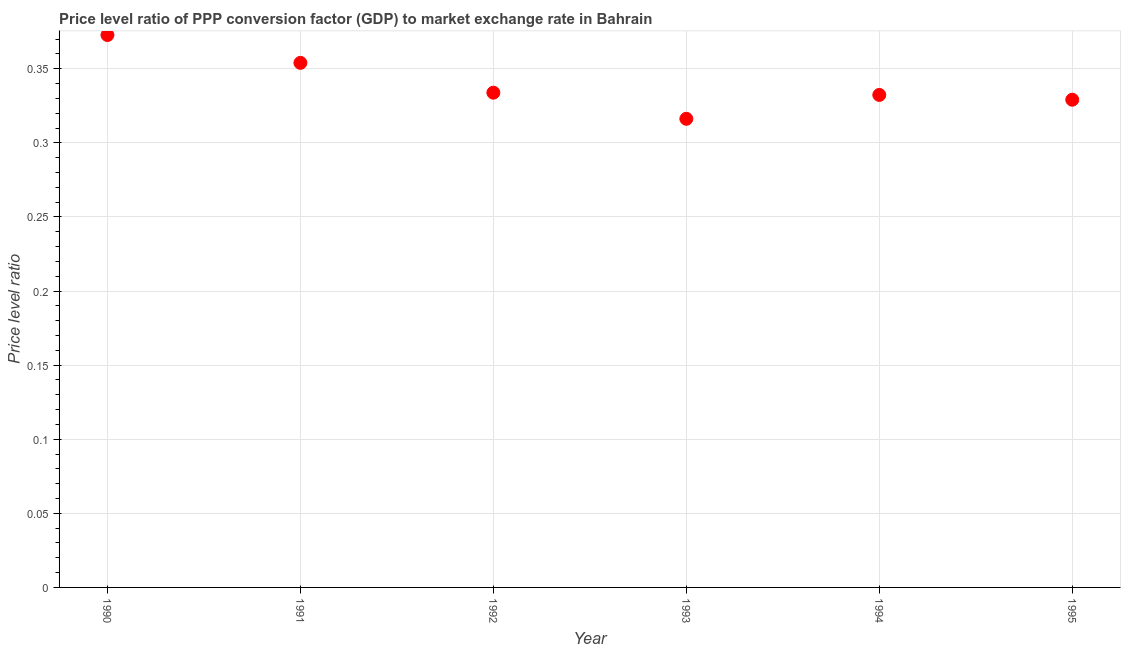What is the price level ratio in 1994?
Give a very brief answer. 0.33. Across all years, what is the maximum price level ratio?
Give a very brief answer. 0.37. Across all years, what is the minimum price level ratio?
Your answer should be very brief. 0.32. In which year was the price level ratio maximum?
Provide a short and direct response. 1990. In which year was the price level ratio minimum?
Provide a succinct answer. 1993. What is the sum of the price level ratio?
Your answer should be compact. 2.04. What is the difference between the price level ratio in 1990 and 1993?
Provide a succinct answer. 0.06. What is the average price level ratio per year?
Provide a short and direct response. 0.34. What is the median price level ratio?
Provide a short and direct response. 0.33. Do a majority of the years between 1993 and 1990 (inclusive) have price level ratio greater than 0.29 ?
Your answer should be compact. Yes. What is the ratio of the price level ratio in 1990 to that in 1992?
Give a very brief answer. 1.12. Is the difference between the price level ratio in 1991 and 1994 greater than the difference between any two years?
Ensure brevity in your answer.  No. What is the difference between the highest and the second highest price level ratio?
Your answer should be compact. 0.02. What is the difference between the highest and the lowest price level ratio?
Provide a short and direct response. 0.06. Does the graph contain any zero values?
Your response must be concise. No. What is the title of the graph?
Make the answer very short. Price level ratio of PPP conversion factor (GDP) to market exchange rate in Bahrain. What is the label or title of the Y-axis?
Offer a terse response. Price level ratio. What is the Price level ratio in 1990?
Your answer should be very brief. 0.37. What is the Price level ratio in 1991?
Provide a succinct answer. 0.35. What is the Price level ratio in 1992?
Offer a terse response. 0.33. What is the Price level ratio in 1993?
Ensure brevity in your answer.  0.32. What is the Price level ratio in 1994?
Your answer should be very brief. 0.33. What is the Price level ratio in 1995?
Give a very brief answer. 0.33. What is the difference between the Price level ratio in 1990 and 1991?
Your response must be concise. 0.02. What is the difference between the Price level ratio in 1990 and 1992?
Offer a very short reply. 0.04. What is the difference between the Price level ratio in 1990 and 1993?
Your answer should be compact. 0.06. What is the difference between the Price level ratio in 1990 and 1994?
Keep it short and to the point. 0.04. What is the difference between the Price level ratio in 1990 and 1995?
Your answer should be very brief. 0.04. What is the difference between the Price level ratio in 1991 and 1992?
Keep it short and to the point. 0.02. What is the difference between the Price level ratio in 1991 and 1993?
Keep it short and to the point. 0.04. What is the difference between the Price level ratio in 1991 and 1994?
Your answer should be very brief. 0.02. What is the difference between the Price level ratio in 1991 and 1995?
Offer a very short reply. 0.02. What is the difference between the Price level ratio in 1992 and 1993?
Provide a succinct answer. 0.02. What is the difference between the Price level ratio in 1992 and 1994?
Offer a very short reply. 0. What is the difference between the Price level ratio in 1992 and 1995?
Ensure brevity in your answer.  0. What is the difference between the Price level ratio in 1993 and 1994?
Ensure brevity in your answer.  -0.02. What is the difference between the Price level ratio in 1993 and 1995?
Your answer should be compact. -0.01. What is the difference between the Price level ratio in 1994 and 1995?
Provide a short and direct response. 0. What is the ratio of the Price level ratio in 1990 to that in 1991?
Offer a very short reply. 1.05. What is the ratio of the Price level ratio in 1990 to that in 1992?
Give a very brief answer. 1.12. What is the ratio of the Price level ratio in 1990 to that in 1993?
Your answer should be compact. 1.18. What is the ratio of the Price level ratio in 1990 to that in 1994?
Offer a very short reply. 1.12. What is the ratio of the Price level ratio in 1990 to that in 1995?
Ensure brevity in your answer.  1.13. What is the ratio of the Price level ratio in 1991 to that in 1992?
Make the answer very short. 1.06. What is the ratio of the Price level ratio in 1991 to that in 1993?
Offer a terse response. 1.12. What is the ratio of the Price level ratio in 1991 to that in 1994?
Your answer should be very brief. 1.06. What is the ratio of the Price level ratio in 1991 to that in 1995?
Make the answer very short. 1.08. What is the ratio of the Price level ratio in 1992 to that in 1993?
Your answer should be very brief. 1.06. What is the ratio of the Price level ratio in 1992 to that in 1995?
Provide a short and direct response. 1.01. What is the ratio of the Price level ratio in 1993 to that in 1995?
Provide a short and direct response. 0.96. What is the ratio of the Price level ratio in 1994 to that in 1995?
Offer a terse response. 1.01. 